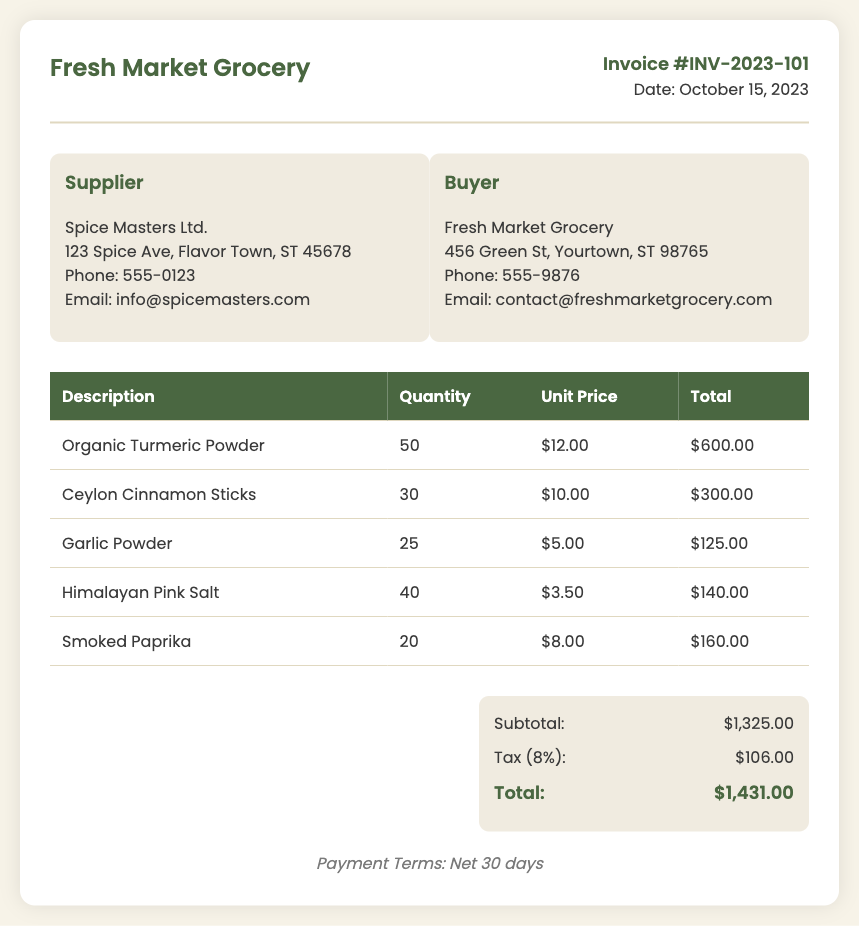What is the invoice number? The invoice number is presented in the document header and is labeled clearly.
Answer: INV-2023-101 Who is the supplier? The supplier's details, including the name, are provided in the company details section of the invoice.
Answer: Spice Masters Ltd What is the date of the invoice? The date is mentioned in the invoice header, indicating when the transaction occurred.
Answer: October 15, 2023 What is the subtotal amount? The subtotal is listed in the summary section of the invoice, summarizing the total costs before tax.
Answer: $1,325.00 How many units of Organic Turmeric Powder were ordered? The ordered quantity of Organic Turmeric Powder is specified in the itemized table of the invoice.
Answer: 50 What is the tax percentage applied? The tax percentage is stated in the summary section alongside the tax amount.
Answer: 8% What is the total amount due? The total amount is the final figure calculated after the subtotal and tax, appearing in the summary.
Answer: $1,431.00 What are the payment terms? The payment terms are mentioned at the bottom of the invoice, specifying when payment is expected.
Answer: Net 30 days How much does a unit of Ceylon Cinnamon Sticks cost? The unit price is detailed in the itemized table for each specific spice, in this case, Ceylon Cinnamon Sticks.
Answer: $10.00 How many different items are listed in the invoice? The number of unique items can be counted from the rows in the itemized table of the invoice.
Answer: 5 